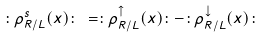<formula> <loc_0><loc_0><loc_500><loc_500>\colon \rho _ { R / L } ^ { s } ( x ) \colon \, = \colon \rho _ { R / L } ^ { \uparrow } ( x ) \colon - \colon \rho _ { R / L } ^ { \downarrow } ( x ) \colon</formula> 